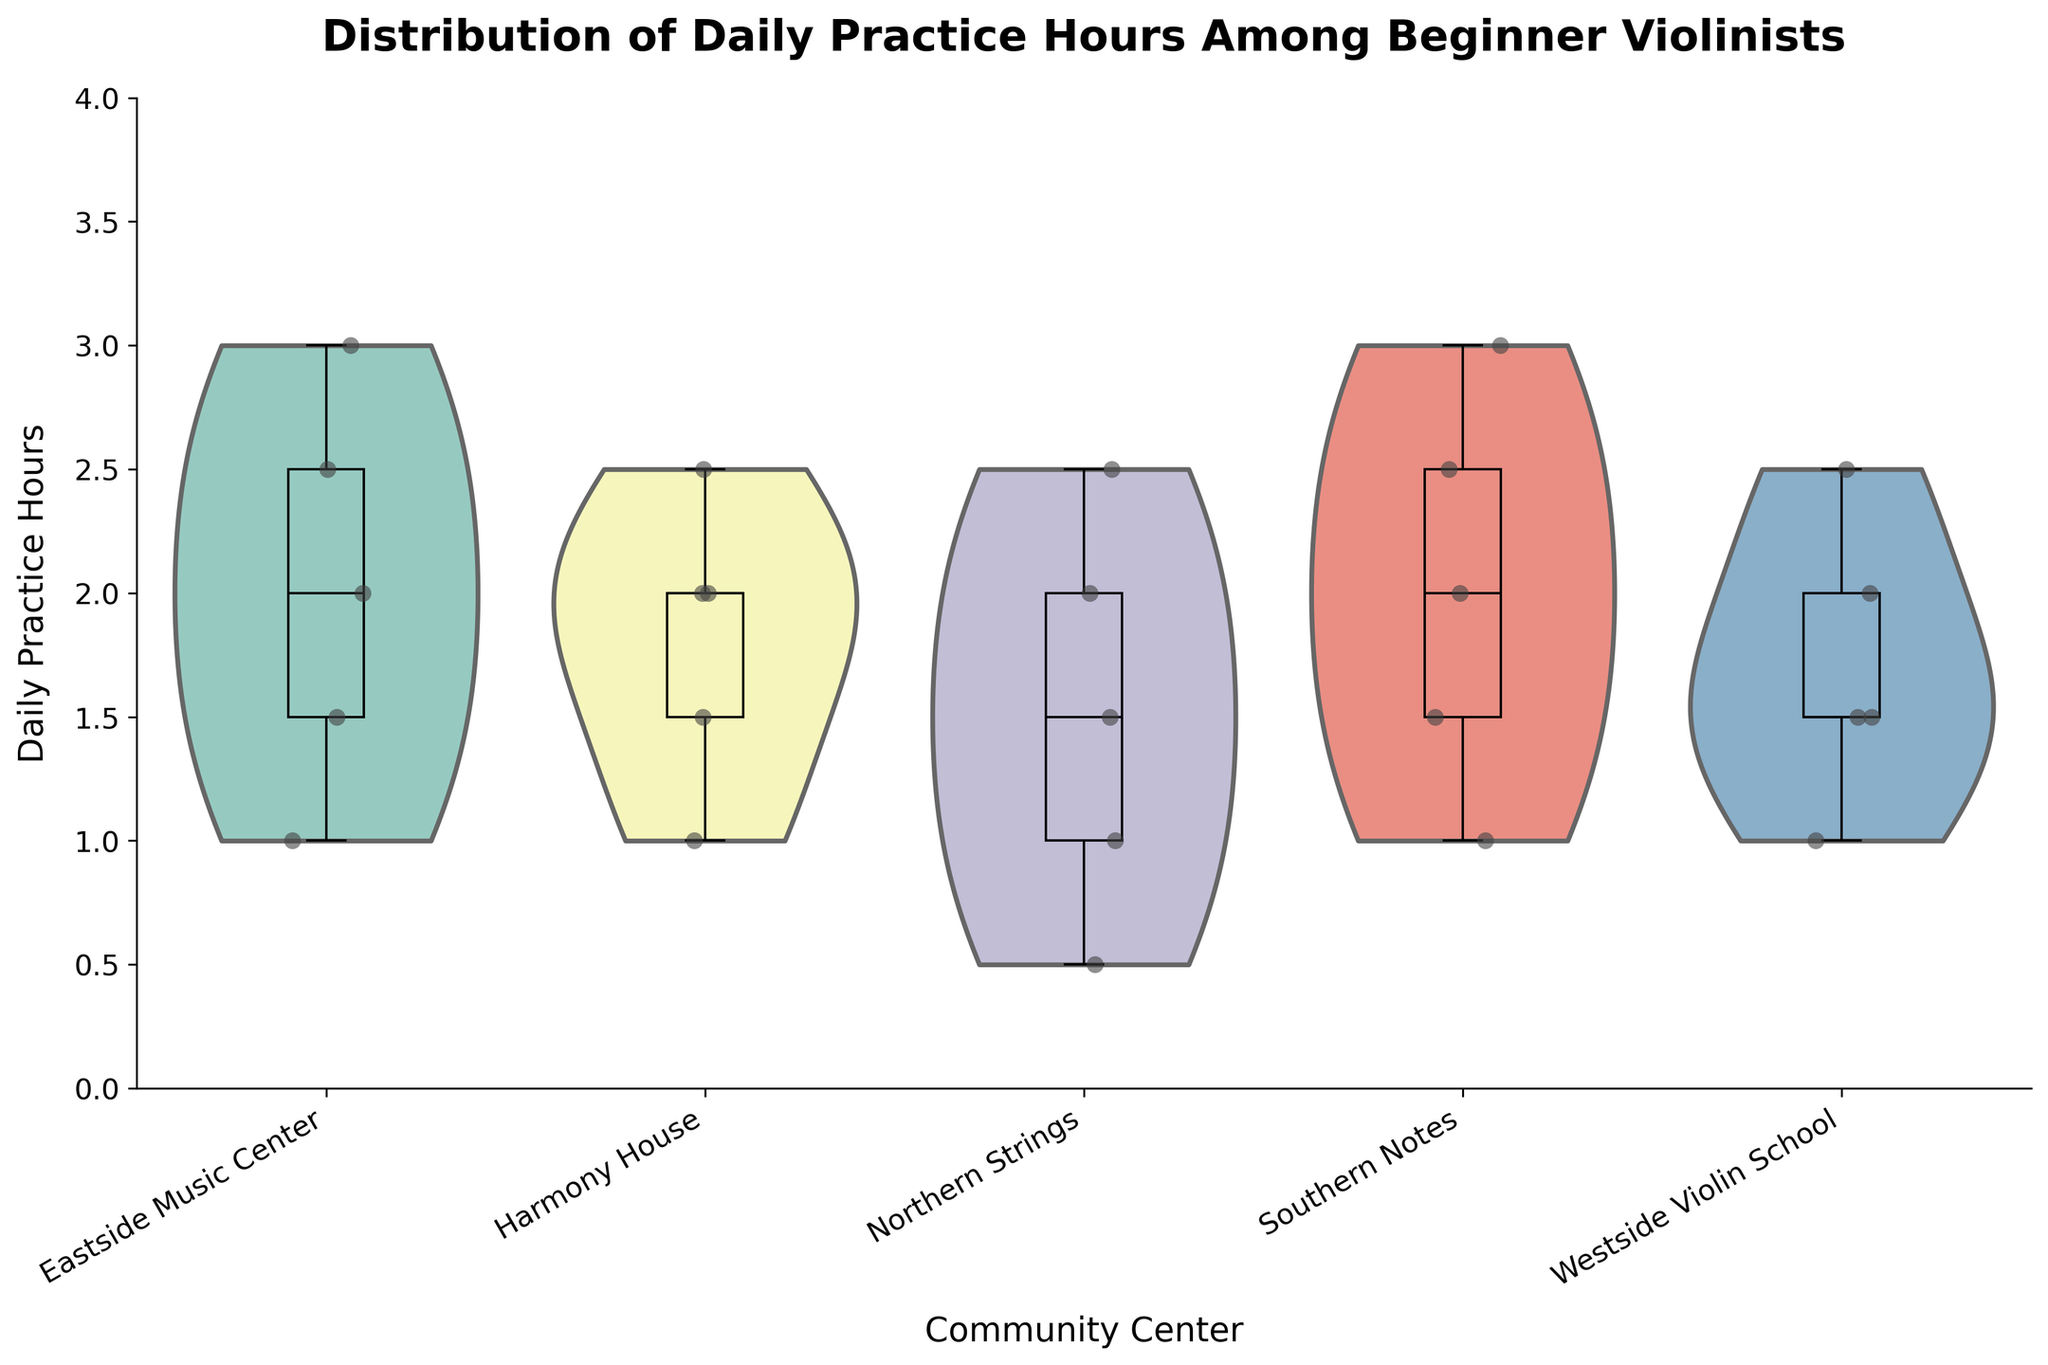What is the title of the figure? The title is usually positioned at the top of the figure, and it is often the largest text for easy identification. In this case, the title "Distribution of Daily Practice Hours Among Beginner Violinists" is visible at the top.
Answer: Distribution of Daily Practice Hours Among Beginner Violinists How many community centers are represented in the figure? To find the number of categories on the x-axis, look for the unique labels. The figure has five x-axis labels, one for each community center.
Answer: Five Which community center has the widest range of daily practice hours? Identify the length of the box in the box plot. Northern Strings shows the widest range as its box extends from around 0.5 to 2.5 hours.
Answer: Northern Strings What is the median daily practice hour at Harmony House? The median is the line inside the box of the box plot. For Harmony House, the median line is at 2 hours.
Answer: 2 hours Which community center has the highest maximum daily practice hours? Identify the top edge of the whiskers in the box plot. Southern Notes and Eastside Music Center both have their top whisker at 3 hours.
Answer: Southern Notes and Eastside Music Center What is the interquartile range (IQR) of daily practice hours at Westside Violin School? The IQR is the range within the box from Q1 to Q3. At Westside Violin School, Q1 is at 1.5 hours, and Q3 is at 2 hours. IQR = Q3 - Q1 = 2 - 1.5 = 0.5 hours.
Answer: 0.5 hours Which community center shows the least variability in daily practice hours? Identify the box with the smallest vertical span. Westside Violin School has the smallest vertical span, indicating the least variability.
Answer: Westside Violin School How do the distributions of daily practice hours at Harmony House and Eastside Music Center compare in terms of symmetry? Look at the shape of the violin plots for symmetry. Harmony House’s violin plot is roughly symmetric, while Eastside Music Center's appears slightly skewed to the right.
Answer: Harmony House is symmetric, Eastside Music Center is slightly skewed right 